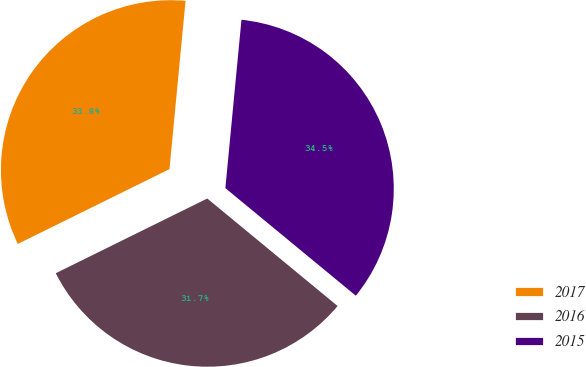<chart> <loc_0><loc_0><loc_500><loc_500><pie_chart><fcel>2017<fcel>2016<fcel>2015<nl><fcel>33.81%<fcel>31.73%<fcel>34.46%<nl></chart> 